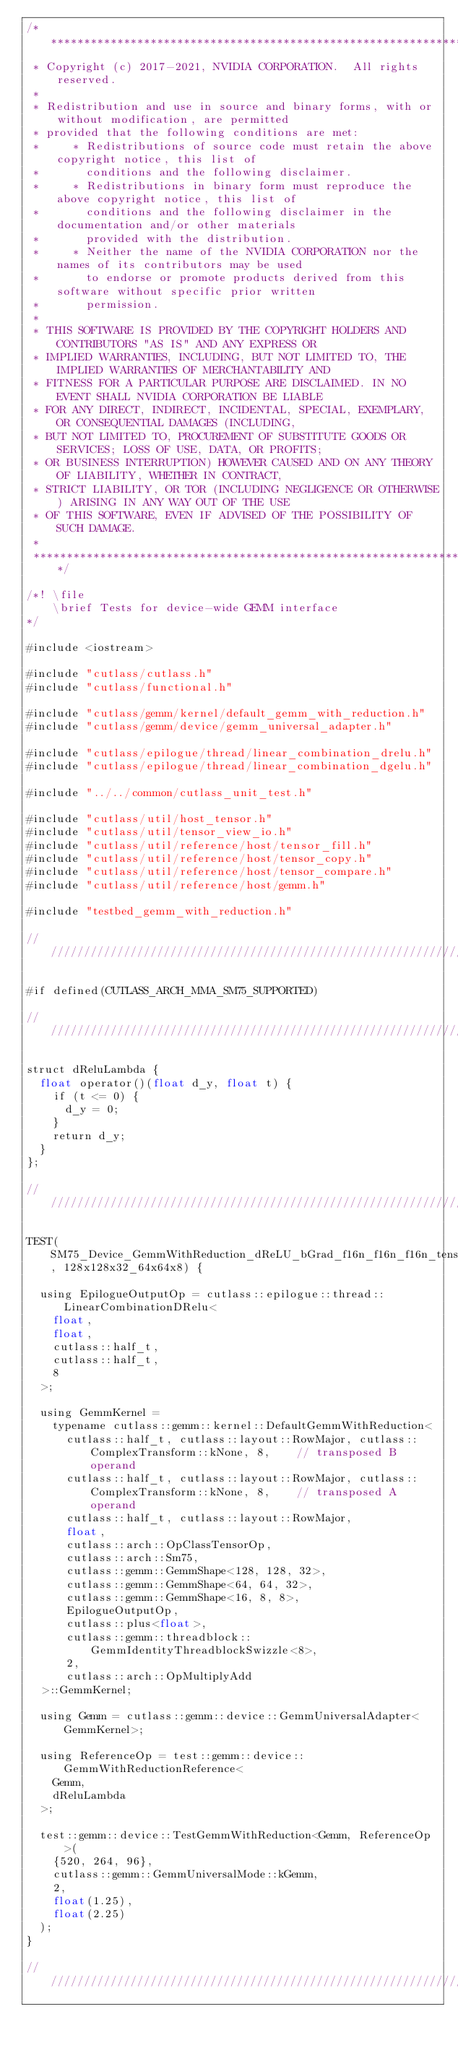<code> <loc_0><loc_0><loc_500><loc_500><_Cuda_>/***************************************************************************************************
 * Copyright (c) 2017-2021, NVIDIA CORPORATION.  All rights reserved.
 *
 * Redistribution and use in source and binary forms, with or without modification, are permitted
 * provided that the following conditions are met:
 *     * Redistributions of source code must retain the above copyright notice, this list of
 *       conditions and the following disclaimer.
 *     * Redistributions in binary form must reproduce the above copyright notice, this list of
 *       conditions and the following disclaimer in the documentation and/or other materials
 *       provided with the distribution.
 *     * Neither the name of the NVIDIA CORPORATION nor the names of its contributors may be used
 *       to endorse or promote products derived from this software without specific prior written
 *       permission.
 *
 * THIS SOFTWARE IS PROVIDED BY THE COPYRIGHT HOLDERS AND CONTRIBUTORS "AS IS" AND ANY EXPRESS OR
 * IMPLIED WARRANTIES, INCLUDING, BUT NOT LIMITED TO, THE IMPLIED WARRANTIES OF MERCHANTABILITY AND
 * FITNESS FOR A PARTICULAR PURPOSE ARE DISCLAIMED. IN NO EVENT SHALL NVIDIA CORPORATION BE LIABLE
 * FOR ANY DIRECT, INDIRECT, INCIDENTAL, SPECIAL, EXEMPLARY, OR CONSEQUENTIAL DAMAGES (INCLUDING,
 * BUT NOT LIMITED TO, PROCUREMENT OF SUBSTITUTE GOODS OR SERVICES; LOSS OF USE, DATA, OR PROFITS;
 * OR BUSINESS INTERRUPTION) HOWEVER CAUSED AND ON ANY THEORY OF LIABILITY, WHETHER IN CONTRACT,
 * STRICT LIABILITY, OR TOR (INCLUDING NEGLIGENCE OR OTHERWISE) ARISING IN ANY WAY OUT OF THE USE
 * OF THIS SOFTWARE, EVEN IF ADVISED OF THE POSSIBILITY OF SUCH DAMAGE.
 *
 **************************************************************************************************/

/*! \file
    \brief Tests for device-wide GEMM interface
*/

#include <iostream>

#include "cutlass/cutlass.h"
#include "cutlass/functional.h"

#include "cutlass/gemm/kernel/default_gemm_with_reduction.h"
#include "cutlass/gemm/device/gemm_universal_adapter.h"

#include "cutlass/epilogue/thread/linear_combination_drelu.h"
#include "cutlass/epilogue/thread/linear_combination_dgelu.h"

#include "../../common/cutlass_unit_test.h"

#include "cutlass/util/host_tensor.h"
#include "cutlass/util/tensor_view_io.h"
#include "cutlass/util/reference/host/tensor_fill.h"
#include "cutlass/util/reference/host/tensor_copy.h"
#include "cutlass/util/reference/host/tensor_compare.h"
#include "cutlass/util/reference/host/gemm.h"

#include "testbed_gemm_with_reduction.h"

/////////////////////////////////////////////////////////////////////////////////////////////////

#if defined(CUTLASS_ARCH_MMA_SM75_SUPPORTED)

/////////////////////////////////////////////////////////////////////////////////////////////////

struct dReluLambda {
  float operator()(float d_y, float t) {
    if (t <= 0) {
      d_y = 0;
    }
    return d_y;
  }
};

/////////////////////////////////////////////////////////////////////////////////////////////////

TEST(SM75_Device_GemmWithReduction_dReLU_bGrad_f16n_f16n_f16n_tensor_op_f32, 128x128x32_64x64x8) {
  
  using EpilogueOutputOp = cutlass::epilogue::thread::LinearCombinationDRelu<
    float,
    float,
    cutlass::half_t,
    cutlass::half_t,
    8
  >;

  using GemmKernel = 
    typename cutlass::gemm::kernel::DefaultGemmWithReduction<
      cutlass::half_t, cutlass::layout::RowMajor, cutlass::ComplexTransform::kNone, 8,    // transposed B operand
      cutlass::half_t, cutlass::layout::RowMajor, cutlass::ComplexTransform::kNone, 8,    // transposed A operand
      cutlass::half_t, cutlass::layout::RowMajor,
      float,
      cutlass::arch::OpClassTensorOp,
      cutlass::arch::Sm75,
      cutlass::gemm::GemmShape<128, 128, 32>,
      cutlass::gemm::GemmShape<64, 64, 32>,
      cutlass::gemm::GemmShape<16, 8, 8>,
      EpilogueOutputOp,
      cutlass::plus<float>,
      cutlass::gemm::threadblock::GemmIdentityThreadblockSwizzle<8>,
      2,
      cutlass::arch::OpMultiplyAdd
  >::GemmKernel;

  using Gemm = cutlass::gemm::device::GemmUniversalAdapter<GemmKernel>;

  using ReferenceOp = test::gemm::device::GemmWithReductionReference<
    Gemm, 
    dReluLambda
  >;

  test::gemm::device::TestGemmWithReduction<Gemm, ReferenceOp>(
    {520, 264, 96},
    cutlass::gemm::GemmUniversalMode::kGemm,
    2,
    float(1.25),
    float(2.25)
  );
}

/////////////////////////////////////////////////////////////////////////////////////////////////
</code> 